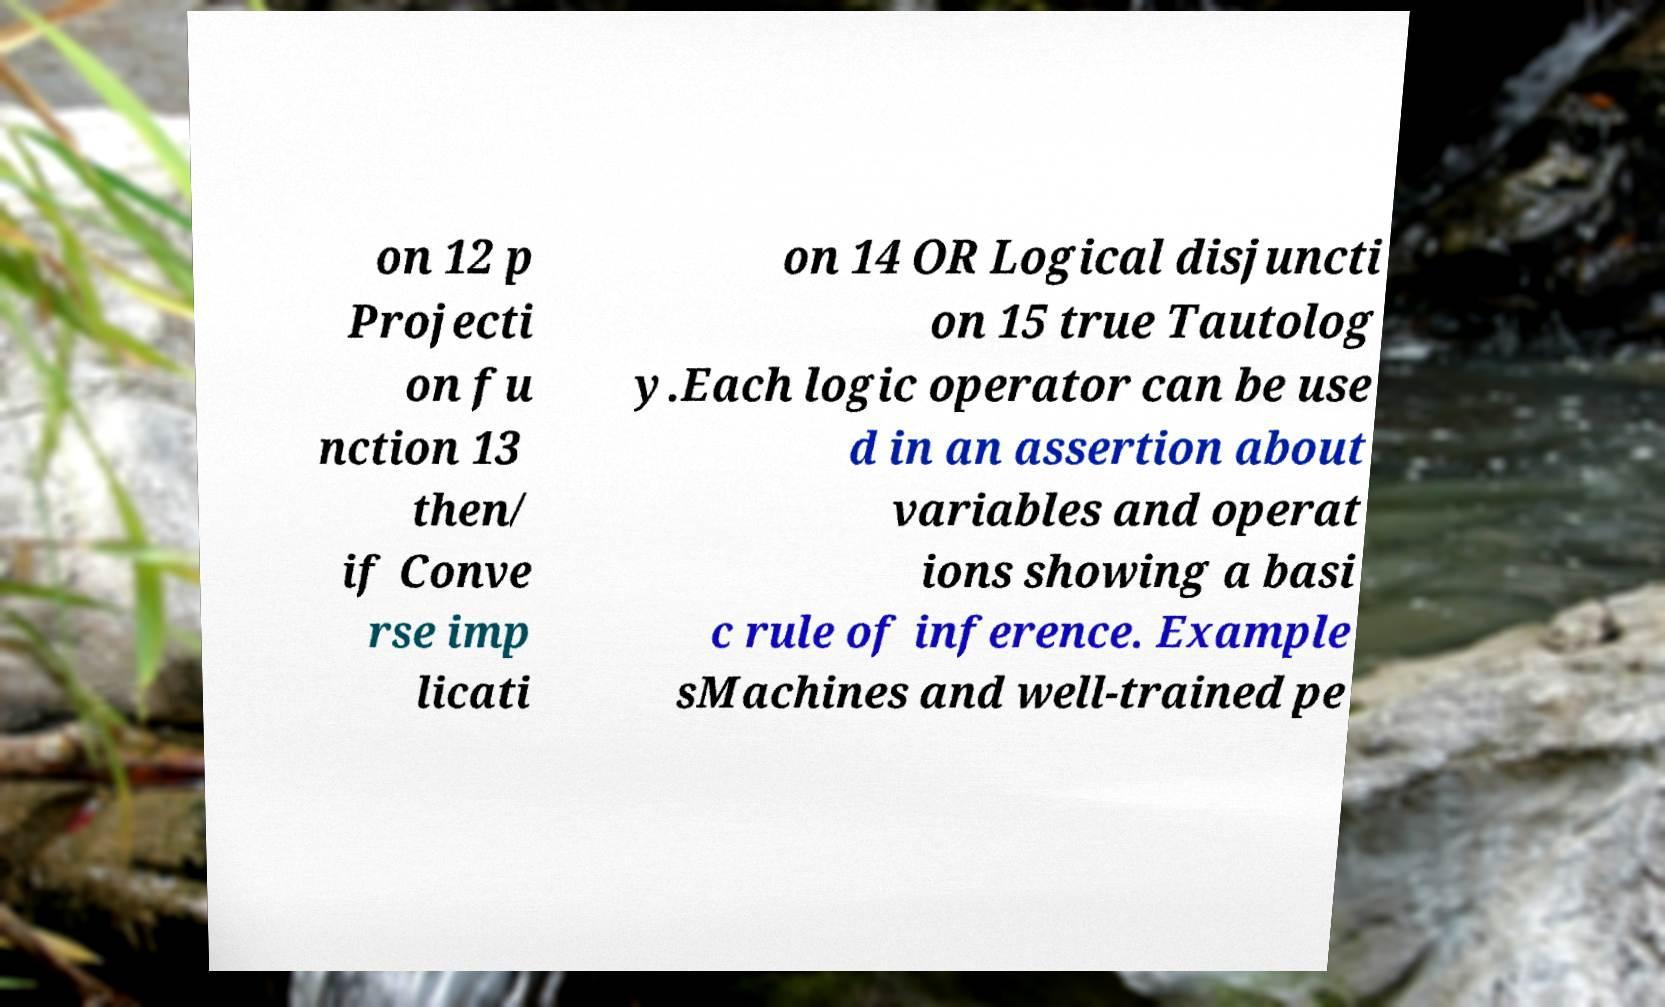Please identify and transcribe the text found in this image. on 12 p Projecti on fu nction 13 then/ if Conve rse imp licati on 14 OR Logical disjuncti on 15 true Tautolog y.Each logic operator can be use d in an assertion about variables and operat ions showing a basi c rule of inference. Example sMachines and well-trained pe 